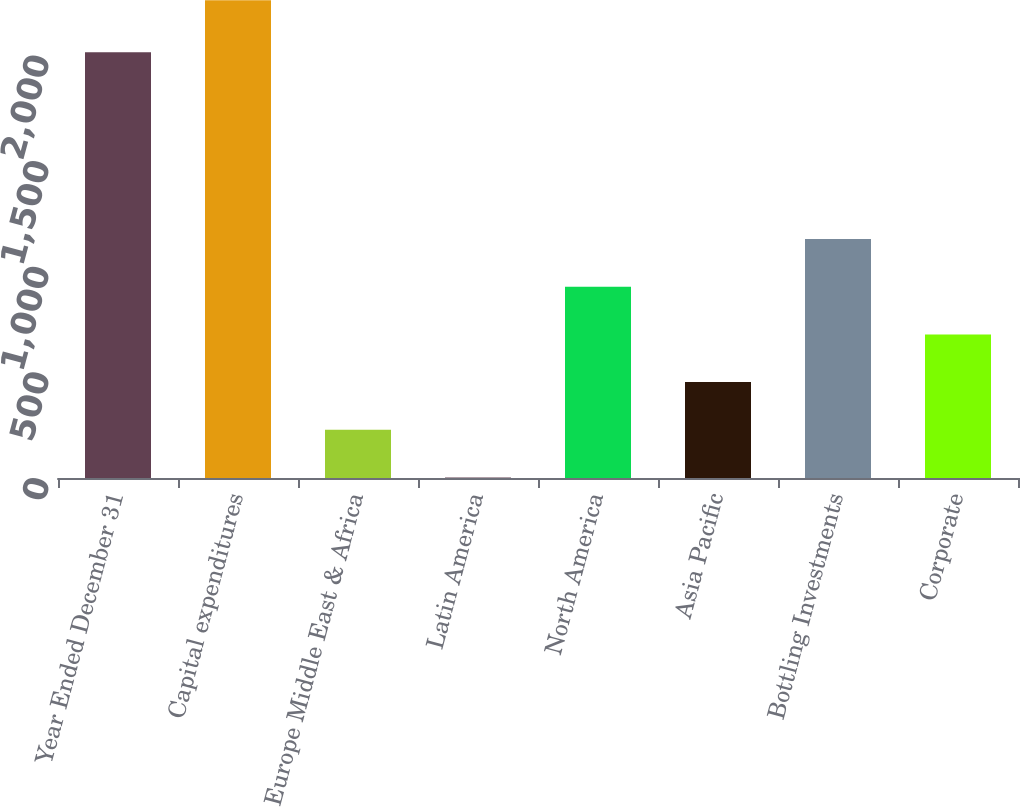Convert chart to OTSL. <chart><loc_0><loc_0><loc_500><loc_500><bar_chart><fcel>Year Ended December 31<fcel>Capital expenditures<fcel>Europe Middle East & Africa<fcel>Latin America<fcel>North America<fcel>Asia Pacific<fcel>Bottling Investments<fcel>Corporate<nl><fcel>2016<fcel>2262<fcel>228<fcel>2<fcel>906<fcel>454<fcel>1132<fcel>680<nl></chart> 